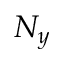Convert formula to latex. <formula><loc_0><loc_0><loc_500><loc_500>N _ { y }</formula> 